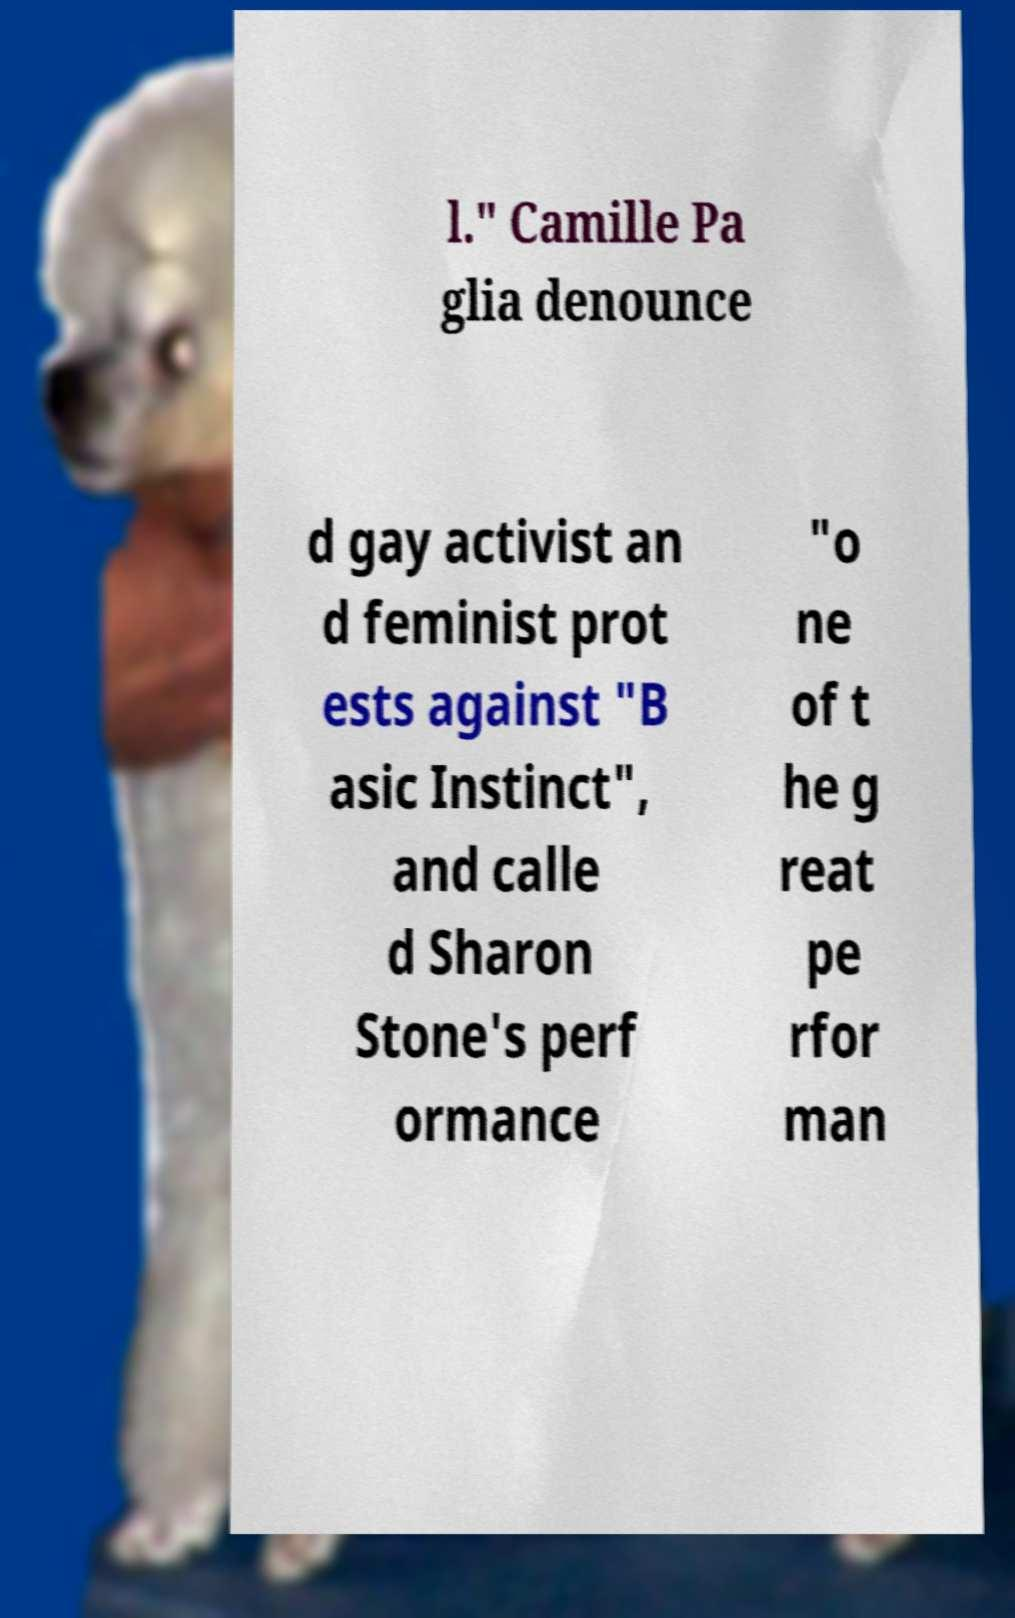I need the written content from this picture converted into text. Can you do that? l." Camille Pa glia denounce d gay activist an d feminist prot ests against "B asic Instinct", and calle d Sharon Stone's perf ormance "o ne of t he g reat pe rfor man 